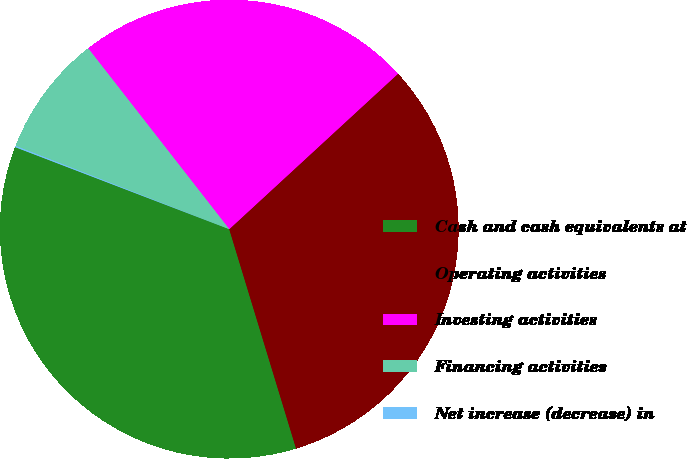<chart> <loc_0><loc_0><loc_500><loc_500><pie_chart><fcel>Cash and cash equivalents at<fcel>Operating activities<fcel>Investing activities<fcel>Financing activities<fcel>Net increase (decrease) in<nl><fcel>35.53%<fcel>32.14%<fcel>23.7%<fcel>8.54%<fcel>0.09%<nl></chart> 